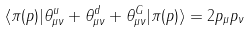Convert formula to latex. <formula><loc_0><loc_0><loc_500><loc_500>\langle \pi ( p ) | \theta _ { \mu \nu } ^ { u } + \theta _ { \mu \nu } ^ { d } + \theta _ { \mu \nu } ^ { G } | \pi ( p ) \rangle = 2 p _ { \mu } p _ { \nu }</formula> 